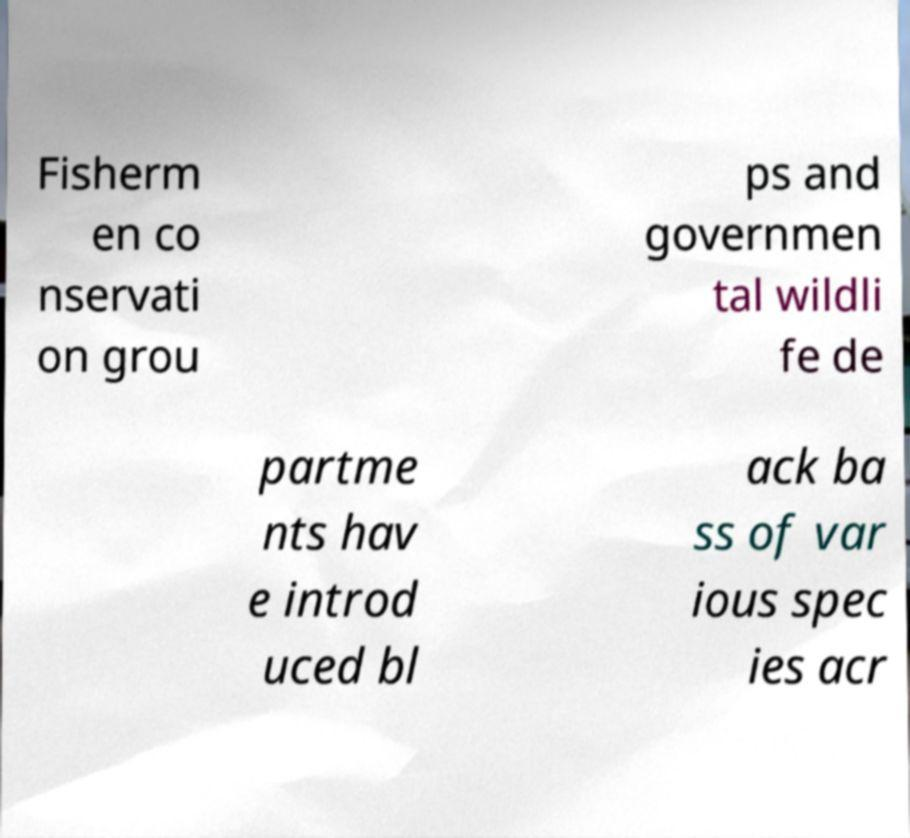I need the written content from this picture converted into text. Can you do that? Fisherm en co nservati on grou ps and governmen tal wildli fe de partme nts hav e introd uced bl ack ba ss of var ious spec ies acr 